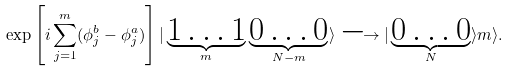Convert formula to latex. <formula><loc_0><loc_0><loc_500><loc_500>\exp \left [ i \sum _ { j = 1 } ^ { m } ( \phi _ { j } ^ { b } - \phi _ { j } ^ { a } ) \right ] | \underbrace { 1 \dots 1 } _ { m } \underbrace { 0 \dots 0 } _ { N - m } \rangle \longrightarrow | \underbrace { 0 \dots 0 } _ { N } \rangle m \rangle .</formula> 